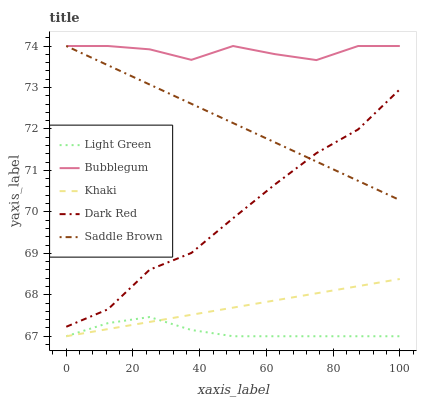Does Light Green have the minimum area under the curve?
Answer yes or no. Yes. Does Bubblegum have the maximum area under the curve?
Answer yes or no. Yes. Does Khaki have the minimum area under the curve?
Answer yes or no. No. Does Khaki have the maximum area under the curve?
Answer yes or no. No. Is Khaki the smoothest?
Answer yes or no. Yes. Is Bubblegum the roughest?
Answer yes or no. Yes. Is Bubblegum the smoothest?
Answer yes or no. No. Is Khaki the roughest?
Answer yes or no. No. Does Bubblegum have the lowest value?
Answer yes or no. No. Does Saddle Brown have the highest value?
Answer yes or no. Yes. Does Khaki have the highest value?
Answer yes or no. No. Is Light Green less than Dark Red?
Answer yes or no. Yes. Is Bubblegum greater than Light Green?
Answer yes or no. Yes. Does Light Green intersect Khaki?
Answer yes or no. Yes. Is Light Green less than Khaki?
Answer yes or no. No. Is Light Green greater than Khaki?
Answer yes or no. No. Does Light Green intersect Dark Red?
Answer yes or no. No. 